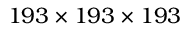<formula> <loc_0><loc_0><loc_500><loc_500>1 9 3 \times 1 9 3 \times 1 9 3</formula> 